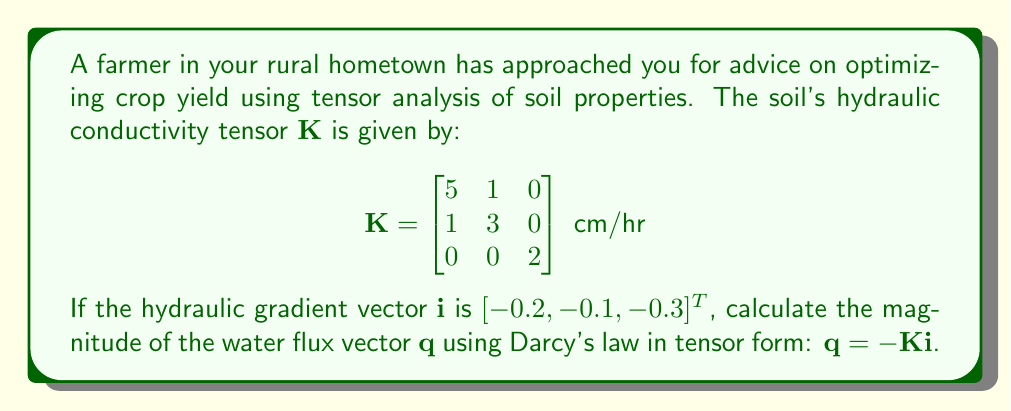Provide a solution to this math problem. To solve this problem, we'll follow these steps:

1) Recall Darcy's law in tensor form: $\mathbf{q} = -\mathbf{K}\mathbf{i}$

2) We are given the hydraulic conductivity tensor $\mathbf{K}$ and the hydraulic gradient vector $\mathbf{i}$:

   $$\mathbf{K} = \begin{bmatrix}
   5 & 1 & 0 \\
   1 & 3 & 0 \\
   0 & 0 & 2
   \end{bmatrix} \text{ cm/hr}$$

   $$\mathbf{i} = \begin{bmatrix}
   -0.2 \\
   -0.1 \\
   -0.3
   \end{bmatrix}$$

3) Multiply $-\mathbf{K}$ and $\mathbf{i}$:

   $$\mathbf{q} = -\begin{bmatrix}
   5 & 1 & 0 \\
   1 & 3 & 0 \\
   0 & 0 & 2
   \end{bmatrix} \begin{bmatrix}
   -0.2 \\
   -0.1 \\
   -0.3
   \end{bmatrix}$$

4) Perform the matrix multiplication:

   $$\mathbf{q} = \begin{bmatrix}
   5(0.2) + 1(0.1) + 0(0.3) \\
   1(0.2) + 3(0.1) + 0(0.3) \\
   0(0.2) + 0(0.1) + 2(0.3)
   \end{bmatrix}$$

5) Simplify:

   $$\mathbf{q} = \begin{bmatrix}
   1.1 \\
   0.5 \\
   0.6
   \end{bmatrix} \text{ cm/hr}$$

6) Calculate the magnitude of $\mathbf{q}$ using the Euclidean norm:

   $$|\mathbf{q}| = \sqrt{(1.1)^2 + (0.5)^2 + (0.6)^2}$$

7) Simplify:

   $$|\mathbf{q}| = \sqrt{1.21 + 0.25 + 0.36} = \sqrt{1.82} \approx 1.35 \text{ cm/hr}$$
Answer: $1.35 \text{ cm/hr}$ 